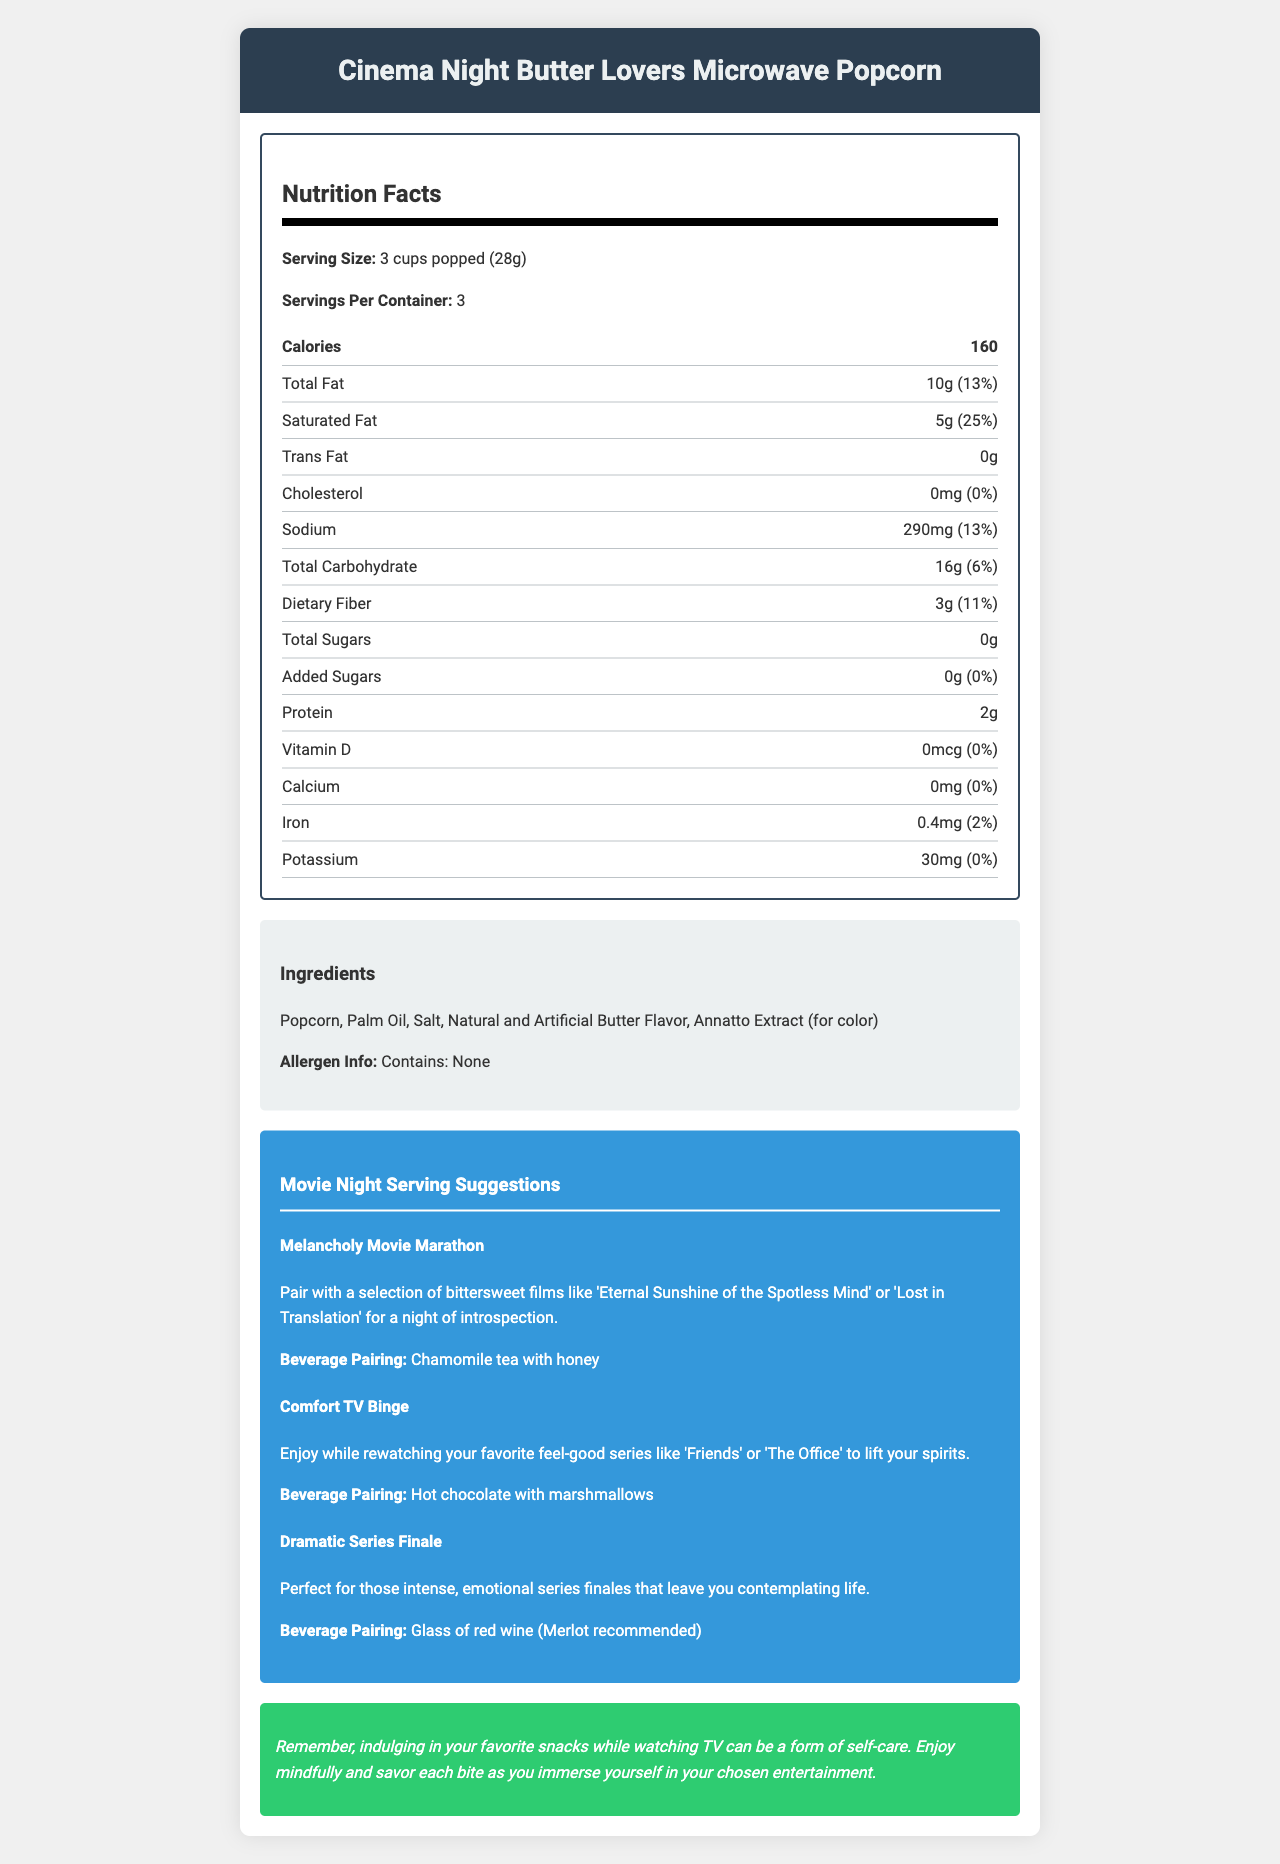what is the serving size of Cinema Night Butter Lovers Microwave Popcorn? The serving size is specified in the document under Nutrition Facts as 3 cups popped (28g).
Answer: 3 cups popped (28g) how many servings are there per container? Under the Nutrition Facts section, it states the number of servings per container as 3.
Answer: 3 what is the calorie count per serving? The Nutrition Facts section lists the calories per serving as 160.
Answer: 160 what percentage of the daily value of saturated fat is in one serving? The daily value of saturated fat is given as 25% in the Nutrition Facts section.
Answer: 25% how much protein is in one serving? The protein content per serving is listed as 2 grams in the Nutrition Facts section.
Answer: 2g what are the main ingredients in Cinema Night Butter Lovers Microwave Popcorn? The ingredients section lists these five main ingredients.
Answer: Popcorn, Palm Oil, Salt, Natural and Artificial Butter Flavor, Annatto Extract which beverage is recommended for a Melancholy Movie Marathon? The Movie Night Serving Suggestions section recommends Chamomile tea with honey for a Melancholy Movie Marathon.
Answer: Chamomile tea with honey is there any cholesterol in Cinema Night Butter Lovers Microwave Popcorn? The Nutrition Facts section shows that the cholesterol amount is 0mg with a daily value of 0%.
Answer: No which of the following films is recommended for a Melancholy Movie Marathon? A. The Office B. Eternal Sunshine of the Spotless Mind C. Harry Potter D. Seinfeld The Melancholy Movie Marathon suggestion includes 'Eternal Sunshine of the Spotless Mind'.
Answer: B which beverage pairing goes with a Comfort TV Binge? A. Coffee B. Tea C. Hot chocolate with marshmallows D. Glass of red wine (Merlot recommended) The Comfort TV Binge suggestion pairs with hot chocolate with marshmallows.
Answer: C is the product suitable for people with allergies? The allergen info section states "Contains: None" which implies it is suitable for people with allergies.
Answer: Yes summarize the document in a few sentences. The summary covers the main sections of the document including nutrition facts, ingredients, allergen info, movie night suggestions, and a mood-boosting tip.
Answer: The document provides the nutrition facts, ingredient list, allergen information, and movie night serving suggestions for Cinema Night Butter Lovers Microwave Popcorn. It includes details such as serving size, servings per container, and the nutritional breakdown of calories, fats, carbohydrates, protein, vitamins, and minerals. The document also gives pairing suggestions for different movie or TV watching experiences, along with a mood-boosting tip. how much sugar is added to Cinema Night Butter Lovers Microwave Popcorn? The amount of added sugars is listed as 0g, but it is generally good to cross-check ingredient lists or product details for confirmation.
Answer: Cannot be determined what is the mood-boosting tip provided? This statement is found in the mood-boosting tip section at the end of the document.
Answer: Indulging in your favorite snacks while watching TV can be a form of self-care. Enjoy mindfully and savor each bite as you immerse yourself in your chosen entertainment. 